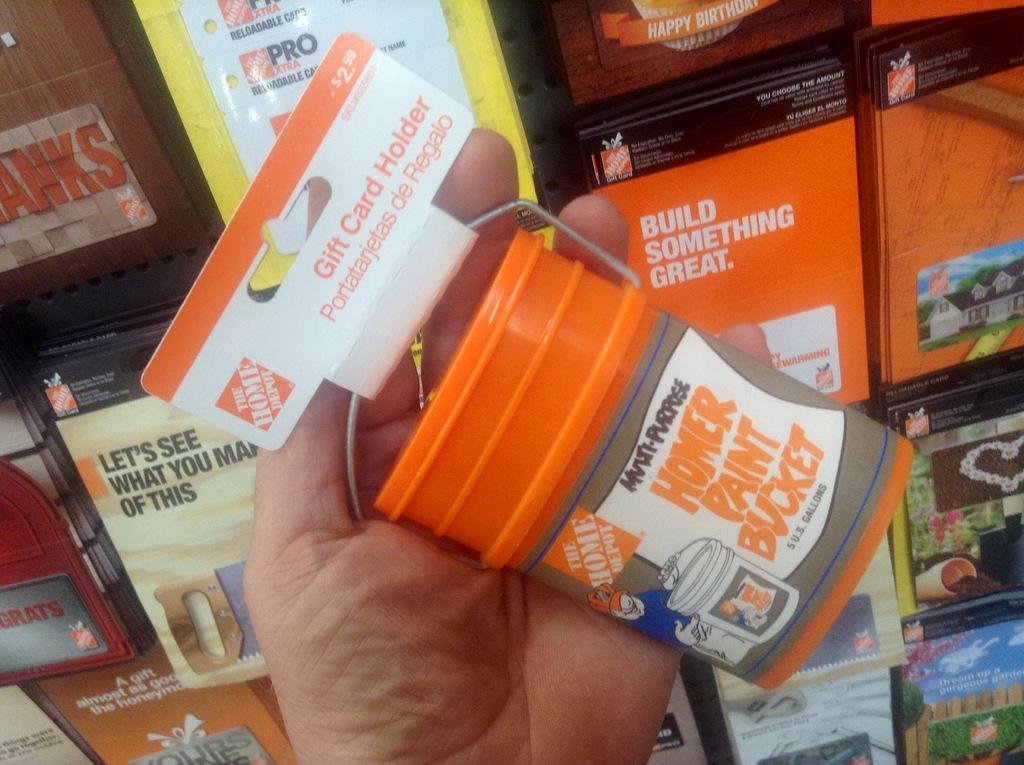<image>
Create a compact narrative representing the image presented. Someone holds a little bucket that is a gift card holder. 